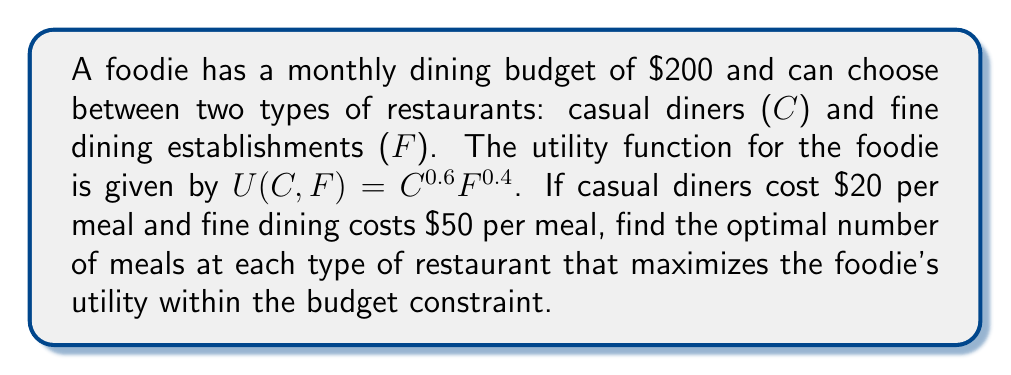Provide a solution to this math problem. 1) First, let's set up the budget constraint equation:
   $20C + 50F = 200$

2) The indifference curve is given by the utility function:
   $U = C^{0.6}F^{0.4}$

3) To find the optimal point, we need to use the tangency condition. The slope of the indifference curve should equal the slope of the budget constraint at the optimal point.

4) Slope of the budget constraint:
   $\frac{dF}{dC} = -\frac{20}{50} = -\frac{2}{5}$

5) Slope of the indifference curve:
   $\frac{dF}{dC} = -\frac{MU_C}{MU_F} = -\frac{0.6C^{-0.4}F^{0.4}}{0.4C^{0.6}F^{-0.6}} = -\frac{3F}{2C}$

6) Setting these slopes equal:
   $\frac{2}{5} = \frac{3F}{2C}$

7) Cross-multiply:
   $4C = 15F$

8) Substitute this into the budget constraint:
   $20(\frac{15F}{4}) + 50F = 200$
   $75F + 50F = 200$
   $125F = 200$
   $F = \frac{8}{5} = 1.6$

9) Substitute back to find C:
   $C = \frac{15F}{4} = \frac{15(1.6)}{4} = 6$

10) Since we can't have fractional meals, we round to the nearest whole number:
    C = 6 meals at casual diners
    F = 2 meals at fine dining establishments
Answer: 6 casual diner meals, 2 fine dining meals 